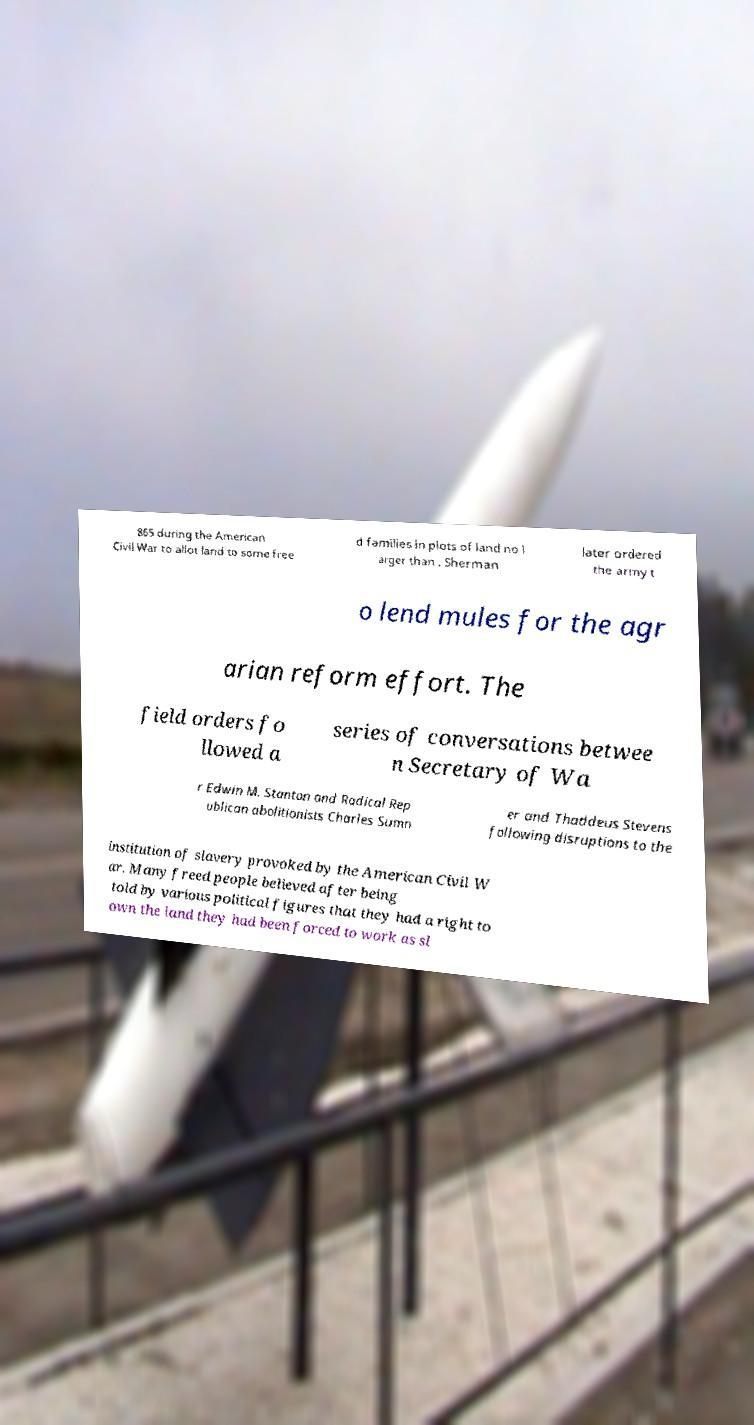I need the written content from this picture converted into text. Can you do that? 865 during the American Civil War to allot land to some free d families in plots of land no l arger than . Sherman later ordered the army t o lend mules for the agr arian reform effort. The field orders fo llowed a series of conversations betwee n Secretary of Wa r Edwin M. Stanton and Radical Rep ublican abolitionists Charles Sumn er and Thaddeus Stevens following disruptions to the institution of slavery provoked by the American Civil W ar. Many freed people believed after being told by various political figures that they had a right to own the land they had been forced to work as sl 